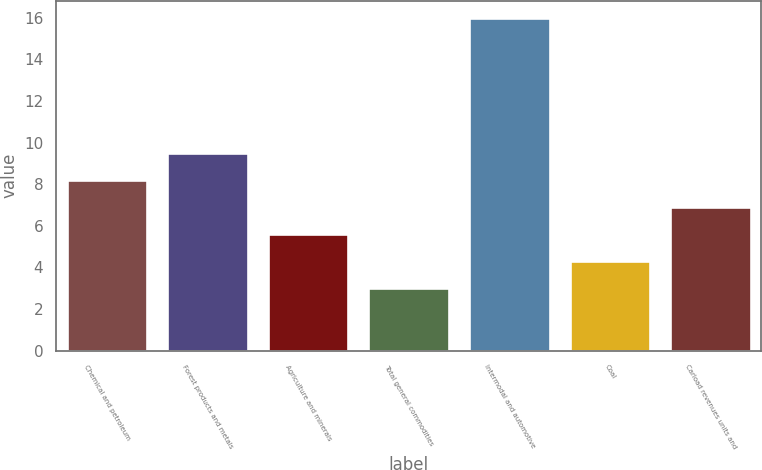Convert chart to OTSL. <chart><loc_0><loc_0><loc_500><loc_500><bar_chart><fcel>Chemical and petroleum<fcel>Forest products and metals<fcel>Agriculture and minerals<fcel>Total general commodities<fcel>Intermodal and automotive<fcel>Coal<fcel>Carload revenues units and<nl><fcel>8.2<fcel>9.5<fcel>5.6<fcel>3<fcel>16<fcel>4.3<fcel>6.9<nl></chart> 